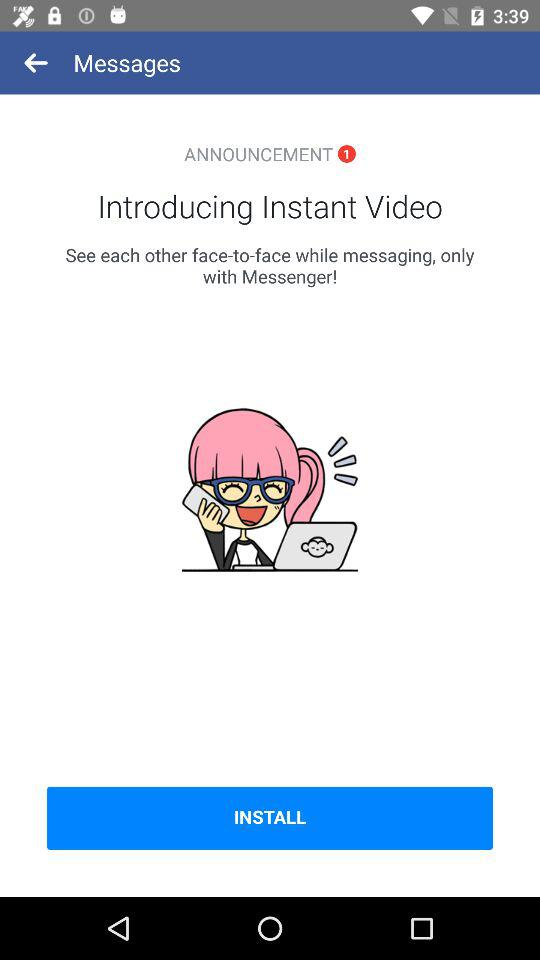How many announcements are there? There is 1 announcement. 